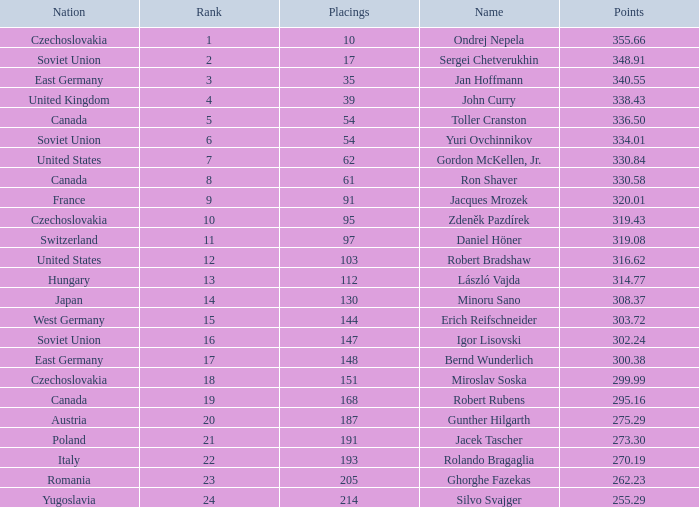How many Placings have Points smaller than 330.84, and a Name of silvo svajger? 1.0. 